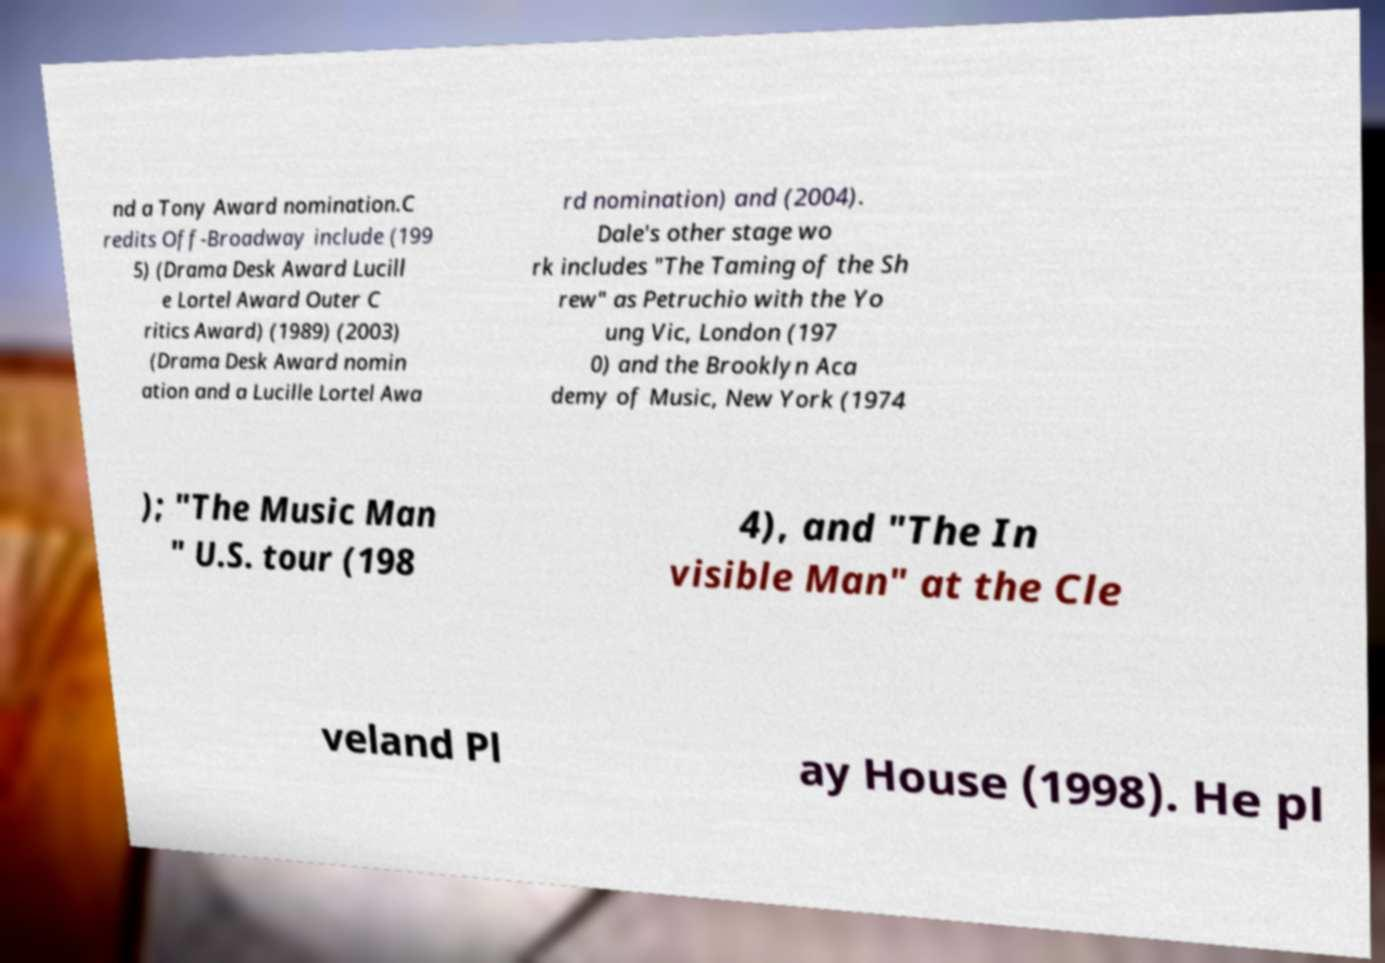For documentation purposes, I need the text within this image transcribed. Could you provide that? nd a Tony Award nomination.C redits Off-Broadway include (199 5) (Drama Desk Award Lucill e Lortel Award Outer C ritics Award) (1989) (2003) (Drama Desk Award nomin ation and a Lucille Lortel Awa rd nomination) and (2004). Dale's other stage wo rk includes "The Taming of the Sh rew" as Petruchio with the Yo ung Vic, London (197 0) and the Brooklyn Aca demy of Music, New York (1974 ); "The Music Man " U.S. tour (198 4), and "The In visible Man" at the Cle veland Pl ay House (1998). He pl 